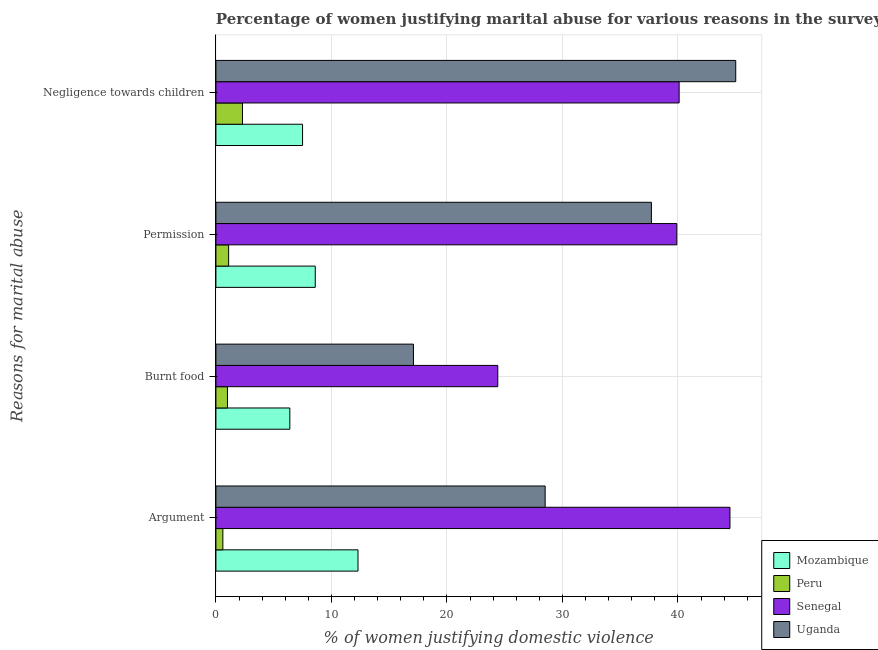How many different coloured bars are there?
Make the answer very short. 4. How many groups of bars are there?
Provide a short and direct response. 4. Are the number of bars on each tick of the Y-axis equal?
Give a very brief answer. Yes. How many bars are there on the 1st tick from the bottom?
Give a very brief answer. 4. What is the label of the 1st group of bars from the top?
Give a very brief answer. Negligence towards children. What is the percentage of women justifying abuse for burning food in Senegal?
Your response must be concise. 24.4. Across all countries, what is the maximum percentage of women justifying abuse for burning food?
Your answer should be very brief. 24.4. Across all countries, what is the minimum percentage of women justifying abuse for showing negligence towards children?
Provide a short and direct response. 2.3. In which country was the percentage of women justifying abuse for going without permission maximum?
Provide a short and direct response. Senegal. What is the total percentage of women justifying abuse for burning food in the graph?
Offer a very short reply. 48.9. What is the difference between the percentage of women justifying abuse for burning food in Senegal and that in Uganda?
Your answer should be very brief. 7.3. What is the difference between the percentage of women justifying abuse in the case of an argument in Mozambique and the percentage of women justifying abuse for going without permission in Senegal?
Offer a very short reply. -27.6. What is the average percentage of women justifying abuse for showing negligence towards children per country?
Give a very brief answer. 23.73. What is the difference between the percentage of women justifying abuse for going without permission and percentage of women justifying abuse in the case of an argument in Senegal?
Give a very brief answer. -4.6. What is the ratio of the percentage of women justifying abuse in the case of an argument in Mozambique to that in Senegal?
Provide a short and direct response. 0.28. Is the percentage of women justifying abuse for showing negligence towards children in Uganda less than that in Mozambique?
Your answer should be very brief. No. Is the difference between the percentage of women justifying abuse for burning food in Senegal and Uganda greater than the difference between the percentage of women justifying abuse in the case of an argument in Senegal and Uganda?
Give a very brief answer. No. What is the difference between the highest and the second highest percentage of women justifying abuse in the case of an argument?
Your answer should be compact. 16. What is the difference between the highest and the lowest percentage of women justifying abuse for burning food?
Offer a terse response. 23.4. In how many countries, is the percentage of women justifying abuse for showing negligence towards children greater than the average percentage of women justifying abuse for showing negligence towards children taken over all countries?
Give a very brief answer. 2. What does the 2nd bar from the top in Permission represents?
Give a very brief answer. Senegal. What does the 2nd bar from the bottom in Negligence towards children represents?
Your answer should be very brief. Peru. Is it the case that in every country, the sum of the percentage of women justifying abuse in the case of an argument and percentage of women justifying abuse for burning food is greater than the percentage of women justifying abuse for going without permission?
Your answer should be very brief. Yes. How many bars are there?
Keep it short and to the point. 16. Are all the bars in the graph horizontal?
Ensure brevity in your answer.  Yes. Are the values on the major ticks of X-axis written in scientific E-notation?
Your answer should be very brief. No. How many legend labels are there?
Provide a succinct answer. 4. What is the title of the graph?
Give a very brief answer. Percentage of women justifying marital abuse for various reasons in the survey of 2011. What is the label or title of the X-axis?
Offer a very short reply. % of women justifying domestic violence. What is the label or title of the Y-axis?
Your answer should be very brief. Reasons for marital abuse. What is the % of women justifying domestic violence in Peru in Argument?
Your answer should be very brief. 0.6. What is the % of women justifying domestic violence in Senegal in Argument?
Your response must be concise. 44.5. What is the % of women justifying domestic violence of Mozambique in Burnt food?
Ensure brevity in your answer.  6.4. What is the % of women justifying domestic violence of Senegal in Burnt food?
Provide a short and direct response. 24.4. What is the % of women justifying domestic violence of Uganda in Burnt food?
Your answer should be very brief. 17.1. What is the % of women justifying domestic violence in Senegal in Permission?
Keep it short and to the point. 39.9. What is the % of women justifying domestic violence of Uganda in Permission?
Offer a very short reply. 37.7. What is the % of women justifying domestic violence in Senegal in Negligence towards children?
Make the answer very short. 40.1. Across all Reasons for marital abuse, what is the maximum % of women justifying domestic violence of Mozambique?
Provide a succinct answer. 12.3. Across all Reasons for marital abuse, what is the maximum % of women justifying domestic violence of Senegal?
Your answer should be very brief. 44.5. Across all Reasons for marital abuse, what is the maximum % of women justifying domestic violence of Uganda?
Keep it short and to the point. 45. Across all Reasons for marital abuse, what is the minimum % of women justifying domestic violence in Mozambique?
Ensure brevity in your answer.  6.4. Across all Reasons for marital abuse, what is the minimum % of women justifying domestic violence in Peru?
Offer a very short reply. 0.6. Across all Reasons for marital abuse, what is the minimum % of women justifying domestic violence of Senegal?
Provide a succinct answer. 24.4. What is the total % of women justifying domestic violence of Mozambique in the graph?
Provide a succinct answer. 34.8. What is the total % of women justifying domestic violence of Peru in the graph?
Give a very brief answer. 5. What is the total % of women justifying domestic violence of Senegal in the graph?
Provide a short and direct response. 148.9. What is the total % of women justifying domestic violence in Uganda in the graph?
Your answer should be very brief. 128.3. What is the difference between the % of women justifying domestic violence of Senegal in Argument and that in Burnt food?
Give a very brief answer. 20.1. What is the difference between the % of women justifying domestic violence in Uganda in Argument and that in Burnt food?
Ensure brevity in your answer.  11.4. What is the difference between the % of women justifying domestic violence in Mozambique in Argument and that in Permission?
Provide a succinct answer. 3.7. What is the difference between the % of women justifying domestic violence of Peru in Argument and that in Permission?
Ensure brevity in your answer.  -0.5. What is the difference between the % of women justifying domestic violence in Senegal in Argument and that in Permission?
Provide a short and direct response. 4.6. What is the difference between the % of women justifying domestic violence in Mozambique in Argument and that in Negligence towards children?
Provide a short and direct response. 4.8. What is the difference between the % of women justifying domestic violence of Uganda in Argument and that in Negligence towards children?
Give a very brief answer. -16.5. What is the difference between the % of women justifying domestic violence in Peru in Burnt food and that in Permission?
Your answer should be compact. -0.1. What is the difference between the % of women justifying domestic violence in Senegal in Burnt food and that in Permission?
Keep it short and to the point. -15.5. What is the difference between the % of women justifying domestic violence in Uganda in Burnt food and that in Permission?
Ensure brevity in your answer.  -20.6. What is the difference between the % of women justifying domestic violence in Mozambique in Burnt food and that in Negligence towards children?
Your answer should be compact. -1.1. What is the difference between the % of women justifying domestic violence in Senegal in Burnt food and that in Negligence towards children?
Offer a very short reply. -15.7. What is the difference between the % of women justifying domestic violence in Uganda in Burnt food and that in Negligence towards children?
Your response must be concise. -27.9. What is the difference between the % of women justifying domestic violence of Mozambique in Permission and that in Negligence towards children?
Your answer should be compact. 1.1. What is the difference between the % of women justifying domestic violence of Peru in Permission and that in Negligence towards children?
Your response must be concise. -1.2. What is the difference between the % of women justifying domestic violence in Senegal in Permission and that in Negligence towards children?
Make the answer very short. -0.2. What is the difference between the % of women justifying domestic violence of Uganda in Permission and that in Negligence towards children?
Provide a succinct answer. -7.3. What is the difference between the % of women justifying domestic violence of Mozambique in Argument and the % of women justifying domestic violence of Peru in Burnt food?
Provide a succinct answer. 11.3. What is the difference between the % of women justifying domestic violence in Mozambique in Argument and the % of women justifying domestic violence in Senegal in Burnt food?
Your answer should be very brief. -12.1. What is the difference between the % of women justifying domestic violence of Peru in Argument and the % of women justifying domestic violence of Senegal in Burnt food?
Give a very brief answer. -23.8. What is the difference between the % of women justifying domestic violence of Peru in Argument and the % of women justifying domestic violence of Uganda in Burnt food?
Offer a terse response. -16.5. What is the difference between the % of women justifying domestic violence in Senegal in Argument and the % of women justifying domestic violence in Uganda in Burnt food?
Your answer should be very brief. 27.4. What is the difference between the % of women justifying domestic violence in Mozambique in Argument and the % of women justifying domestic violence in Senegal in Permission?
Your answer should be compact. -27.6. What is the difference between the % of women justifying domestic violence in Mozambique in Argument and the % of women justifying domestic violence in Uganda in Permission?
Keep it short and to the point. -25.4. What is the difference between the % of women justifying domestic violence of Peru in Argument and the % of women justifying domestic violence of Senegal in Permission?
Your answer should be very brief. -39.3. What is the difference between the % of women justifying domestic violence in Peru in Argument and the % of women justifying domestic violence in Uganda in Permission?
Keep it short and to the point. -37.1. What is the difference between the % of women justifying domestic violence in Mozambique in Argument and the % of women justifying domestic violence in Senegal in Negligence towards children?
Your answer should be very brief. -27.8. What is the difference between the % of women justifying domestic violence in Mozambique in Argument and the % of women justifying domestic violence in Uganda in Negligence towards children?
Your answer should be very brief. -32.7. What is the difference between the % of women justifying domestic violence in Peru in Argument and the % of women justifying domestic violence in Senegal in Negligence towards children?
Ensure brevity in your answer.  -39.5. What is the difference between the % of women justifying domestic violence of Peru in Argument and the % of women justifying domestic violence of Uganda in Negligence towards children?
Your answer should be very brief. -44.4. What is the difference between the % of women justifying domestic violence of Senegal in Argument and the % of women justifying domestic violence of Uganda in Negligence towards children?
Provide a succinct answer. -0.5. What is the difference between the % of women justifying domestic violence of Mozambique in Burnt food and the % of women justifying domestic violence of Peru in Permission?
Your answer should be very brief. 5.3. What is the difference between the % of women justifying domestic violence in Mozambique in Burnt food and the % of women justifying domestic violence in Senegal in Permission?
Offer a very short reply. -33.5. What is the difference between the % of women justifying domestic violence in Mozambique in Burnt food and the % of women justifying domestic violence in Uganda in Permission?
Provide a succinct answer. -31.3. What is the difference between the % of women justifying domestic violence of Peru in Burnt food and the % of women justifying domestic violence of Senegal in Permission?
Keep it short and to the point. -38.9. What is the difference between the % of women justifying domestic violence in Peru in Burnt food and the % of women justifying domestic violence in Uganda in Permission?
Offer a terse response. -36.7. What is the difference between the % of women justifying domestic violence of Senegal in Burnt food and the % of women justifying domestic violence of Uganda in Permission?
Offer a terse response. -13.3. What is the difference between the % of women justifying domestic violence of Mozambique in Burnt food and the % of women justifying domestic violence of Senegal in Negligence towards children?
Give a very brief answer. -33.7. What is the difference between the % of women justifying domestic violence of Mozambique in Burnt food and the % of women justifying domestic violence of Uganda in Negligence towards children?
Keep it short and to the point. -38.6. What is the difference between the % of women justifying domestic violence of Peru in Burnt food and the % of women justifying domestic violence of Senegal in Negligence towards children?
Your response must be concise. -39.1. What is the difference between the % of women justifying domestic violence in Peru in Burnt food and the % of women justifying domestic violence in Uganda in Negligence towards children?
Offer a very short reply. -44. What is the difference between the % of women justifying domestic violence in Senegal in Burnt food and the % of women justifying domestic violence in Uganda in Negligence towards children?
Your response must be concise. -20.6. What is the difference between the % of women justifying domestic violence in Mozambique in Permission and the % of women justifying domestic violence in Peru in Negligence towards children?
Give a very brief answer. 6.3. What is the difference between the % of women justifying domestic violence in Mozambique in Permission and the % of women justifying domestic violence in Senegal in Negligence towards children?
Ensure brevity in your answer.  -31.5. What is the difference between the % of women justifying domestic violence of Mozambique in Permission and the % of women justifying domestic violence of Uganda in Negligence towards children?
Give a very brief answer. -36.4. What is the difference between the % of women justifying domestic violence in Peru in Permission and the % of women justifying domestic violence in Senegal in Negligence towards children?
Your answer should be very brief. -39. What is the difference between the % of women justifying domestic violence of Peru in Permission and the % of women justifying domestic violence of Uganda in Negligence towards children?
Provide a succinct answer. -43.9. What is the average % of women justifying domestic violence in Mozambique per Reasons for marital abuse?
Your answer should be very brief. 8.7. What is the average % of women justifying domestic violence in Senegal per Reasons for marital abuse?
Provide a short and direct response. 37.23. What is the average % of women justifying domestic violence in Uganda per Reasons for marital abuse?
Provide a short and direct response. 32.08. What is the difference between the % of women justifying domestic violence of Mozambique and % of women justifying domestic violence of Peru in Argument?
Your response must be concise. 11.7. What is the difference between the % of women justifying domestic violence of Mozambique and % of women justifying domestic violence of Senegal in Argument?
Your answer should be very brief. -32.2. What is the difference between the % of women justifying domestic violence in Mozambique and % of women justifying domestic violence in Uganda in Argument?
Provide a succinct answer. -16.2. What is the difference between the % of women justifying domestic violence in Peru and % of women justifying domestic violence in Senegal in Argument?
Your answer should be compact. -43.9. What is the difference between the % of women justifying domestic violence of Peru and % of women justifying domestic violence of Uganda in Argument?
Make the answer very short. -27.9. What is the difference between the % of women justifying domestic violence of Mozambique and % of women justifying domestic violence of Peru in Burnt food?
Ensure brevity in your answer.  5.4. What is the difference between the % of women justifying domestic violence of Mozambique and % of women justifying domestic violence of Senegal in Burnt food?
Keep it short and to the point. -18. What is the difference between the % of women justifying domestic violence of Mozambique and % of women justifying domestic violence of Uganda in Burnt food?
Your response must be concise. -10.7. What is the difference between the % of women justifying domestic violence in Peru and % of women justifying domestic violence in Senegal in Burnt food?
Offer a terse response. -23.4. What is the difference between the % of women justifying domestic violence in Peru and % of women justifying domestic violence in Uganda in Burnt food?
Your response must be concise. -16.1. What is the difference between the % of women justifying domestic violence in Senegal and % of women justifying domestic violence in Uganda in Burnt food?
Your response must be concise. 7.3. What is the difference between the % of women justifying domestic violence in Mozambique and % of women justifying domestic violence in Senegal in Permission?
Keep it short and to the point. -31.3. What is the difference between the % of women justifying domestic violence in Mozambique and % of women justifying domestic violence in Uganda in Permission?
Make the answer very short. -29.1. What is the difference between the % of women justifying domestic violence of Peru and % of women justifying domestic violence of Senegal in Permission?
Your response must be concise. -38.8. What is the difference between the % of women justifying domestic violence of Peru and % of women justifying domestic violence of Uganda in Permission?
Keep it short and to the point. -36.6. What is the difference between the % of women justifying domestic violence of Mozambique and % of women justifying domestic violence of Senegal in Negligence towards children?
Provide a short and direct response. -32.6. What is the difference between the % of women justifying domestic violence in Mozambique and % of women justifying domestic violence in Uganda in Negligence towards children?
Offer a very short reply. -37.5. What is the difference between the % of women justifying domestic violence in Peru and % of women justifying domestic violence in Senegal in Negligence towards children?
Make the answer very short. -37.8. What is the difference between the % of women justifying domestic violence in Peru and % of women justifying domestic violence in Uganda in Negligence towards children?
Your answer should be very brief. -42.7. What is the ratio of the % of women justifying domestic violence of Mozambique in Argument to that in Burnt food?
Provide a short and direct response. 1.92. What is the ratio of the % of women justifying domestic violence of Senegal in Argument to that in Burnt food?
Provide a short and direct response. 1.82. What is the ratio of the % of women justifying domestic violence in Mozambique in Argument to that in Permission?
Your response must be concise. 1.43. What is the ratio of the % of women justifying domestic violence in Peru in Argument to that in Permission?
Provide a short and direct response. 0.55. What is the ratio of the % of women justifying domestic violence of Senegal in Argument to that in Permission?
Provide a succinct answer. 1.12. What is the ratio of the % of women justifying domestic violence in Uganda in Argument to that in Permission?
Provide a succinct answer. 0.76. What is the ratio of the % of women justifying domestic violence of Mozambique in Argument to that in Negligence towards children?
Your response must be concise. 1.64. What is the ratio of the % of women justifying domestic violence of Peru in Argument to that in Negligence towards children?
Your answer should be compact. 0.26. What is the ratio of the % of women justifying domestic violence in Senegal in Argument to that in Negligence towards children?
Offer a very short reply. 1.11. What is the ratio of the % of women justifying domestic violence in Uganda in Argument to that in Negligence towards children?
Ensure brevity in your answer.  0.63. What is the ratio of the % of women justifying domestic violence in Mozambique in Burnt food to that in Permission?
Give a very brief answer. 0.74. What is the ratio of the % of women justifying domestic violence of Peru in Burnt food to that in Permission?
Give a very brief answer. 0.91. What is the ratio of the % of women justifying domestic violence of Senegal in Burnt food to that in Permission?
Offer a terse response. 0.61. What is the ratio of the % of women justifying domestic violence of Uganda in Burnt food to that in Permission?
Offer a terse response. 0.45. What is the ratio of the % of women justifying domestic violence in Mozambique in Burnt food to that in Negligence towards children?
Offer a terse response. 0.85. What is the ratio of the % of women justifying domestic violence of Peru in Burnt food to that in Negligence towards children?
Make the answer very short. 0.43. What is the ratio of the % of women justifying domestic violence in Senegal in Burnt food to that in Negligence towards children?
Make the answer very short. 0.61. What is the ratio of the % of women justifying domestic violence in Uganda in Burnt food to that in Negligence towards children?
Give a very brief answer. 0.38. What is the ratio of the % of women justifying domestic violence in Mozambique in Permission to that in Negligence towards children?
Offer a terse response. 1.15. What is the ratio of the % of women justifying domestic violence of Peru in Permission to that in Negligence towards children?
Your answer should be compact. 0.48. What is the ratio of the % of women justifying domestic violence in Uganda in Permission to that in Negligence towards children?
Your answer should be very brief. 0.84. What is the difference between the highest and the second highest % of women justifying domestic violence in Mozambique?
Give a very brief answer. 3.7. What is the difference between the highest and the second highest % of women justifying domestic violence of Uganda?
Your answer should be compact. 7.3. What is the difference between the highest and the lowest % of women justifying domestic violence in Mozambique?
Make the answer very short. 5.9. What is the difference between the highest and the lowest % of women justifying domestic violence of Senegal?
Your answer should be very brief. 20.1. What is the difference between the highest and the lowest % of women justifying domestic violence of Uganda?
Provide a succinct answer. 27.9. 